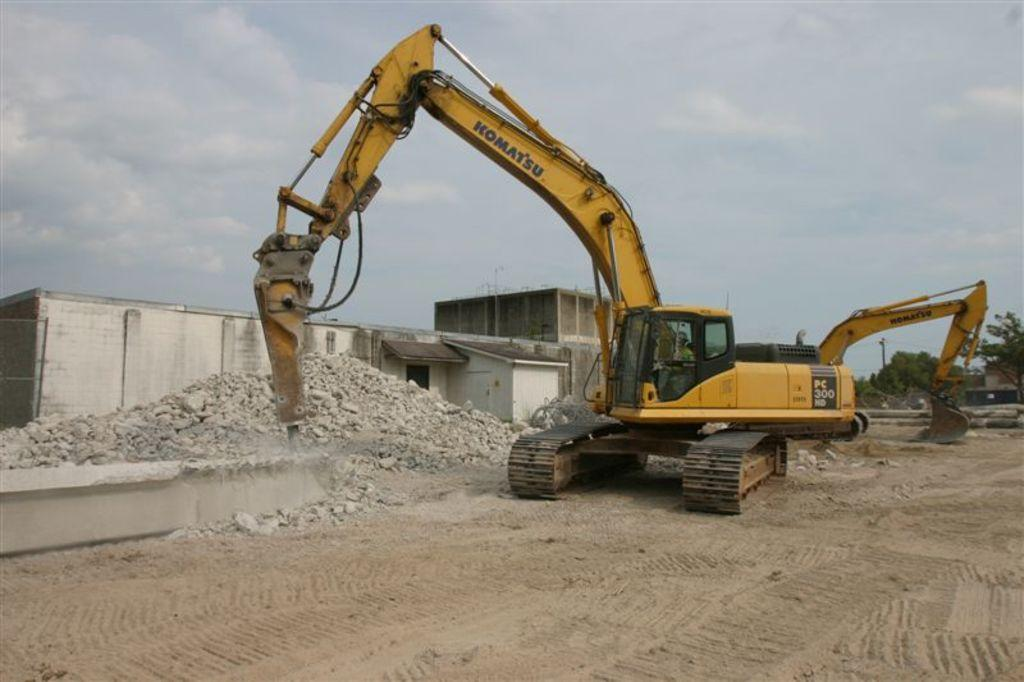What is the main subject of the image? There is a vehicle in the image. What colors are used for the vehicle? The vehicle has yellow and black colors. What can be seen in the background of the image? There are trees, buildings, stones, and a pole visible in the background. What is the color of the sky in the image? The sky is visible in the image, with white and blue colors. What title is given to the prison in the image? There is no prison present in the image, so there is no title to be given. What causes the vehicle to burst in the image? There is no indication in the image that the vehicle is bursting or experiencing any damage. 